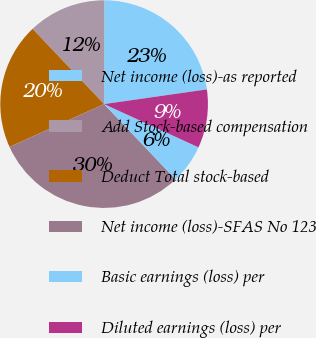<chart> <loc_0><loc_0><loc_500><loc_500><pie_chart><fcel>Net income (loss)-as reported<fcel>Add Stock-based compensation<fcel>Deduct Total stock-based<fcel>Net income (loss)-SFAS No 123<fcel>Basic earnings (loss) per<fcel>Diluted earnings (loss) per<nl><fcel>22.71%<fcel>12.13%<fcel>19.67%<fcel>30.33%<fcel>6.07%<fcel>9.1%<nl></chart> 